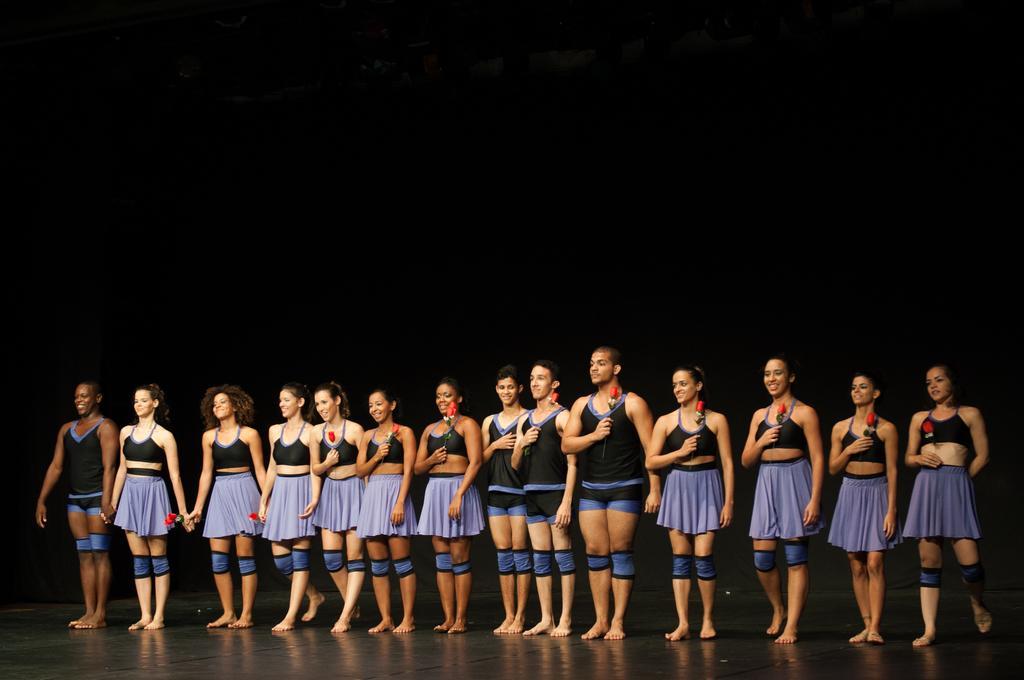Can you describe this image briefly? Here I can see few women and men wearing same dresses, holding flowers in the hands, standing on the stage, smiling and giving pose for the picture. The background is dark. 